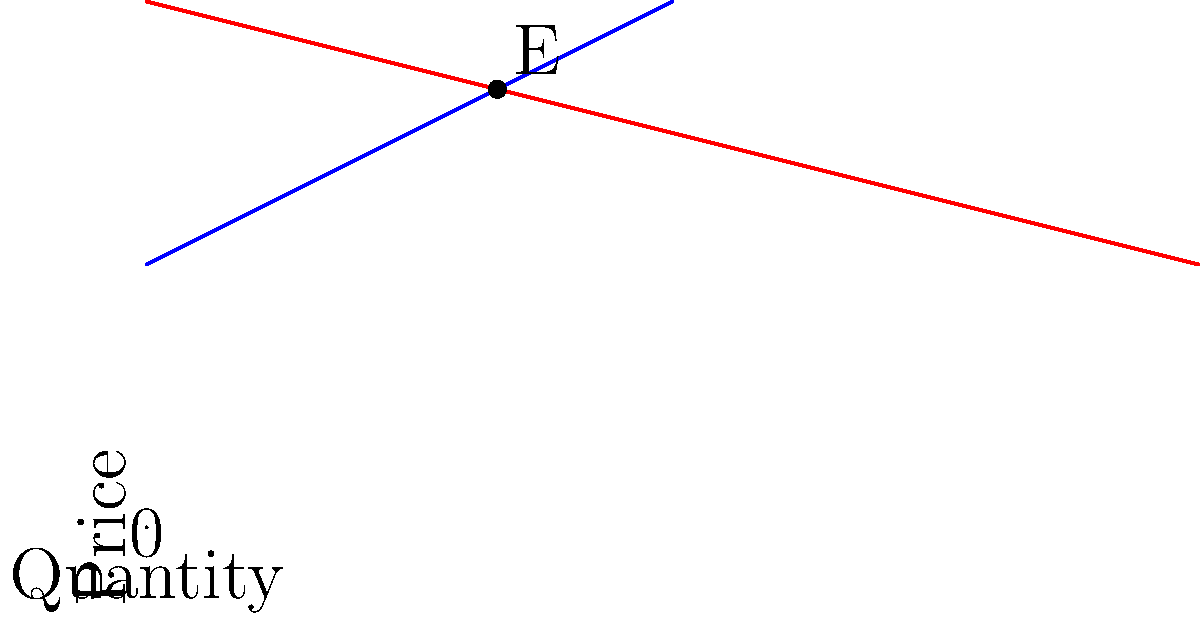In a monopolistic market, the intersection of the demand and supply curves doesn't determine the equilibrium price and quantity. Given the graph above, if the monopolist decides to maximize profit, what would be the optimal quantity produced? To answer this question, we need to understand the profit-maximizing behavior of a monopolist:

1. In a competitive market, the equilibrium would be at point E, where supply meets demand.

2. However, a monopolist can set the price or quantity to maximize profit.

3. The profit-maximizing point occurs where Marginal Revenue (MR) equals Marginal Cost (MC).

4. The MR curve is not shown in this graph, but it always lies below the demand curve for a monopolist.

5. The MC curve is represented by the supply curve in this simplified model.

6. Therefore, the profit-maximizing quantity will be less than the intersection point quantity.

7. Without additional information about the exact demand function or cost structure, we cannot determine the precise optimal quantity.

8. However, we can conclude that the optimal quantity will be less than 6.67 units (the quantity at point E).

This analysis showcases how monopolistic markets differ from perfectly competitive markets, a key concept in economic theory and policy debates.
Answer: Less than 6.67 units 